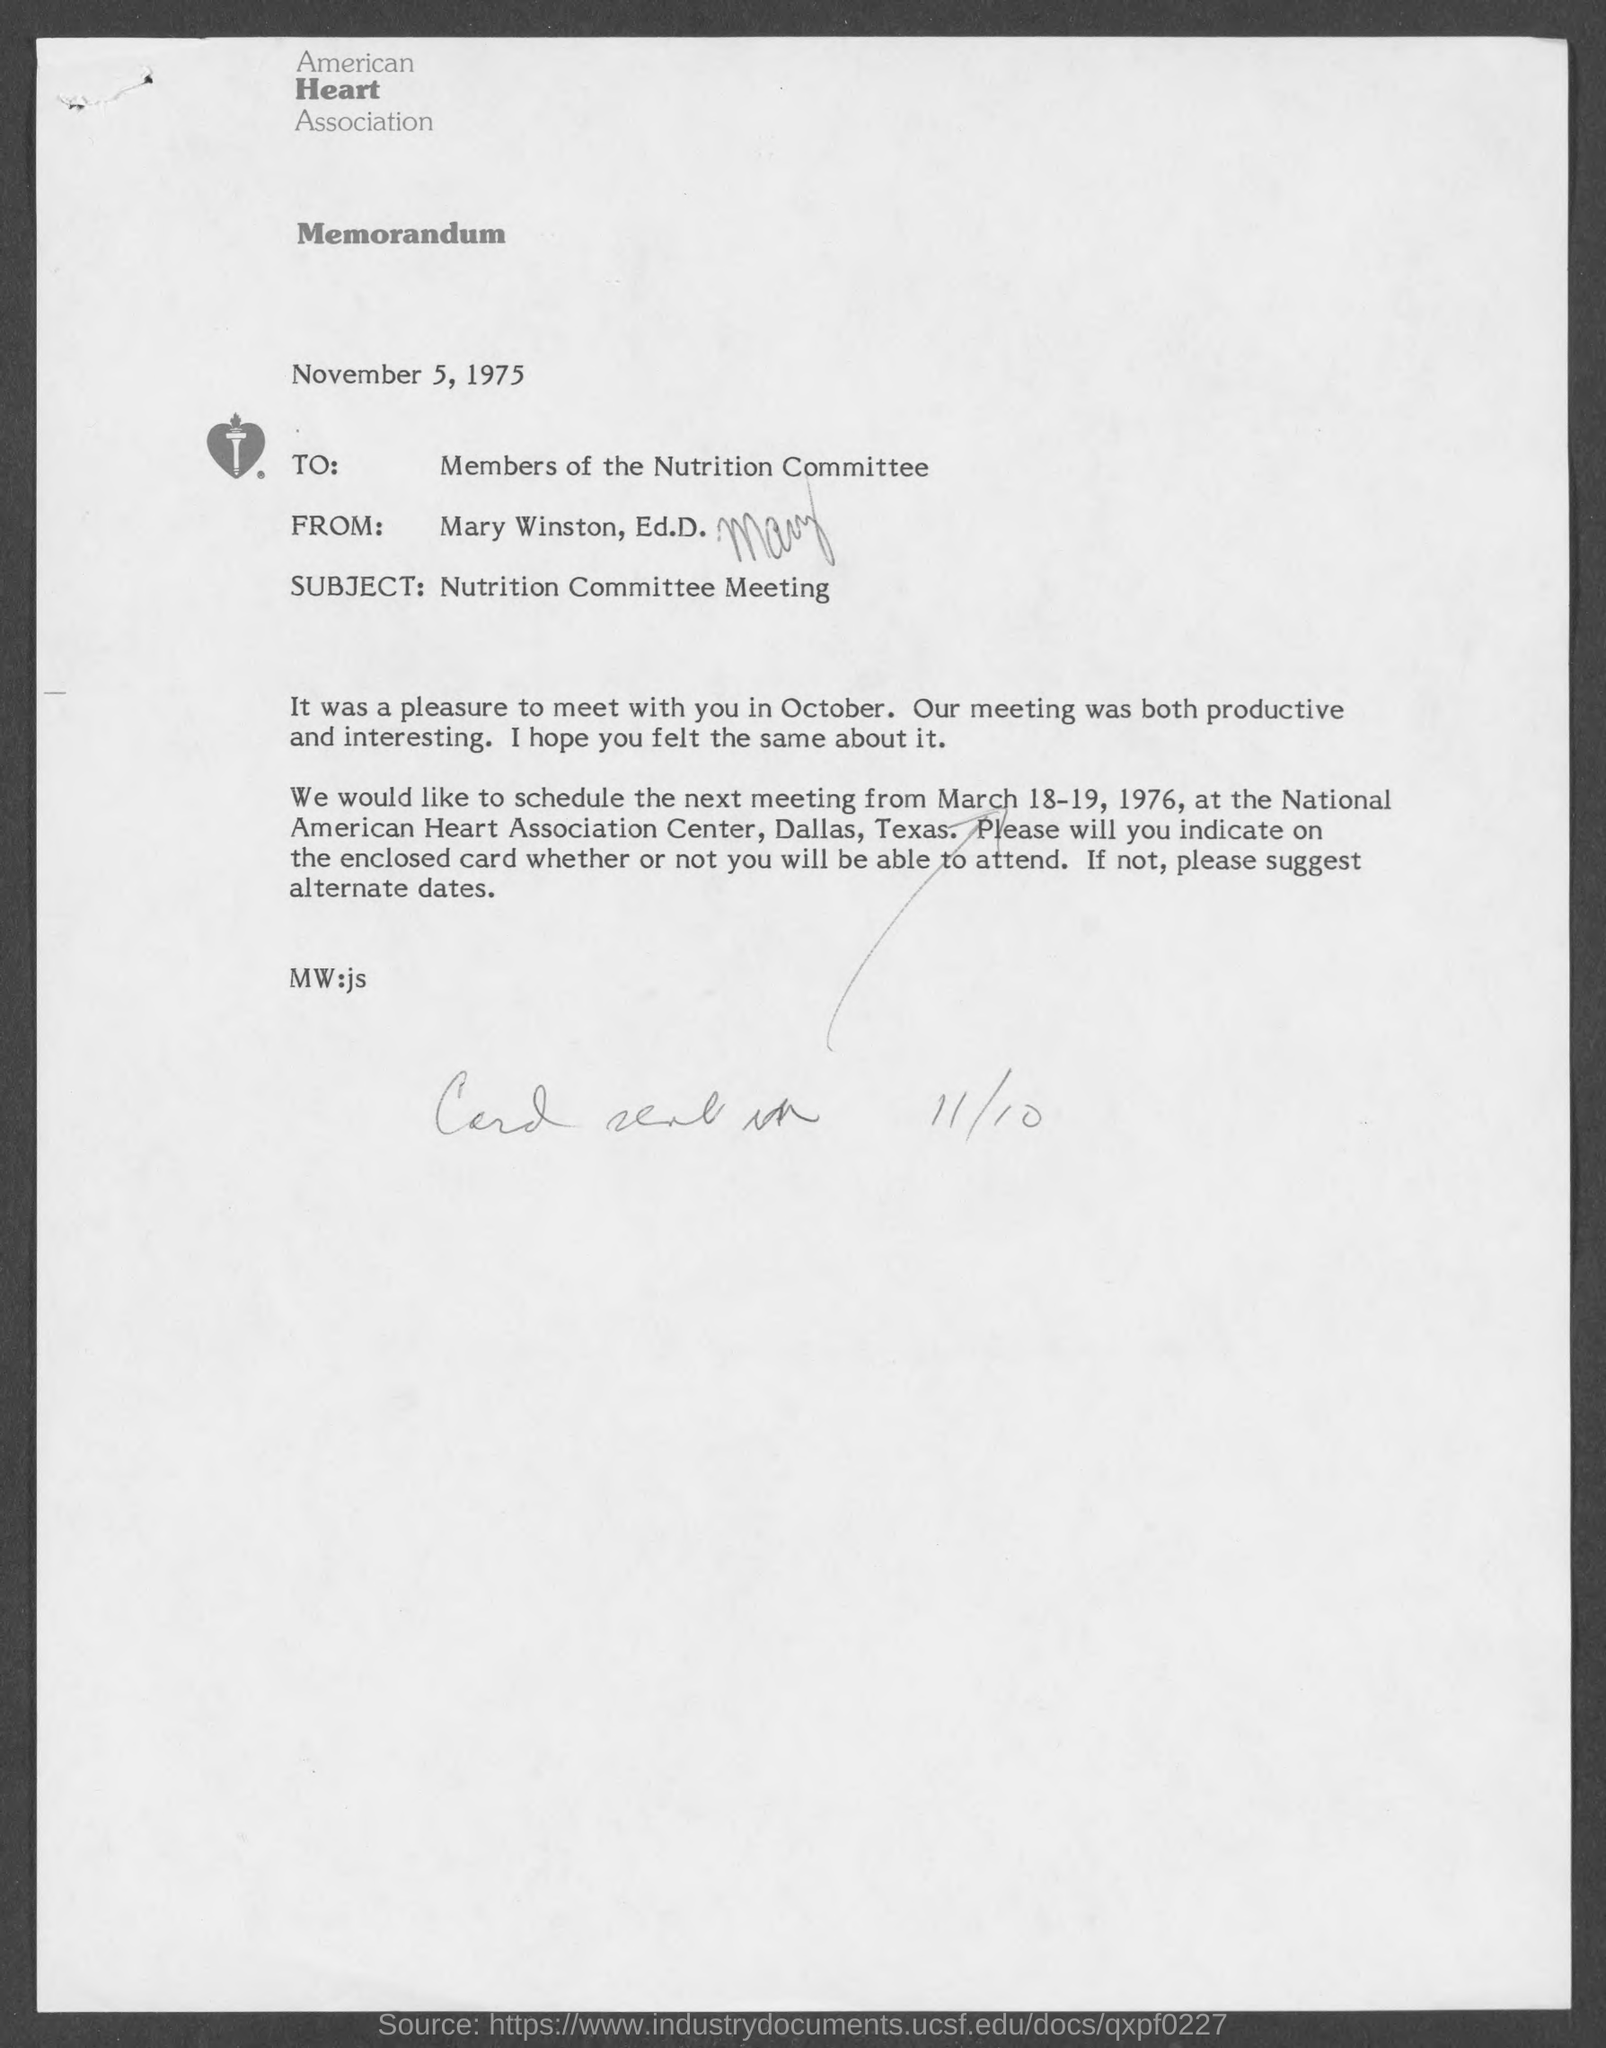What is the name of the heart association ?
Give a very brief answer. American heart association. What is the subject of memorandum ?
Ensure brevity in your answer.  Nutrition committee meeting. What is the from address in memorandum ?
Your answer should be compact. Mary winston, ed.d. To whom is the memorandum written to?
Give a very brief answer. Members of nutrition committee. 